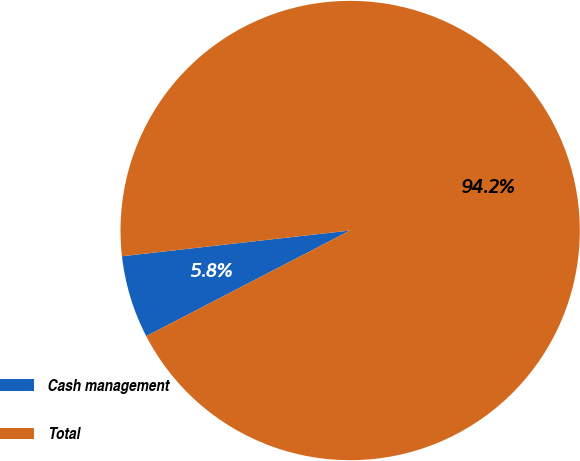Convert chart to OTSL. <chart><loc_0><loc_0><loc_500><loc_500><pie_chart><fcel>Cash management<fcel>Total<nl><fcel>5.82%<fcel>94.18%<nl></chart> 